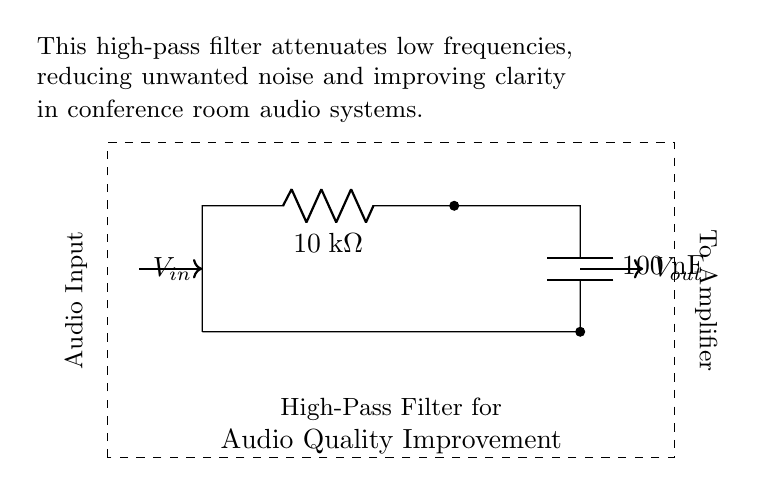What type of filter is represented by this circuit? The circuit is designed as a high-pass filter, which allows high frequencies to pass through while attenuating low frequencies. This is evident from the arrangement of the resistor and capacitor, which is typical for high-pass filtering.
Answer: high-pass filter What is the resistance value in this circuit? The circuit contains a resistor labeled at ten thousand ohms, which is specified in the circuit diagram.
Answer: ten thousand ohms What is the capacitance value in this circuit? The circuit includes a capacitor labeled at one hundred nanofarads, indicating its capacitance value.
Answer: one hundred nanofarads What is the purpose of this high-pass filter in the audio system? The filter's main purpose is to attenuate low frequencies, which helps reduce unwanted noise and improve the clarity of the audio signal during conferences. This is referenced directly in the notes on the circuit.
Answer: reduce unwanted noise What does the output signal connect to in this circuit? The output of the circuit is directed to an amplifier, as indicated by the connection labeled "To Amplifier." This shows the next stage for processing the filtered audio signal.
Answer: amplifier What happens to low frequencies in this circuit? Low frequencies are attenuated by the high-pass filter, meaning they are reduced in amplitude and are less likely to pass through the circuit to the output. This characteristic helps enhance overall audio quality.
Answer: attenuated 